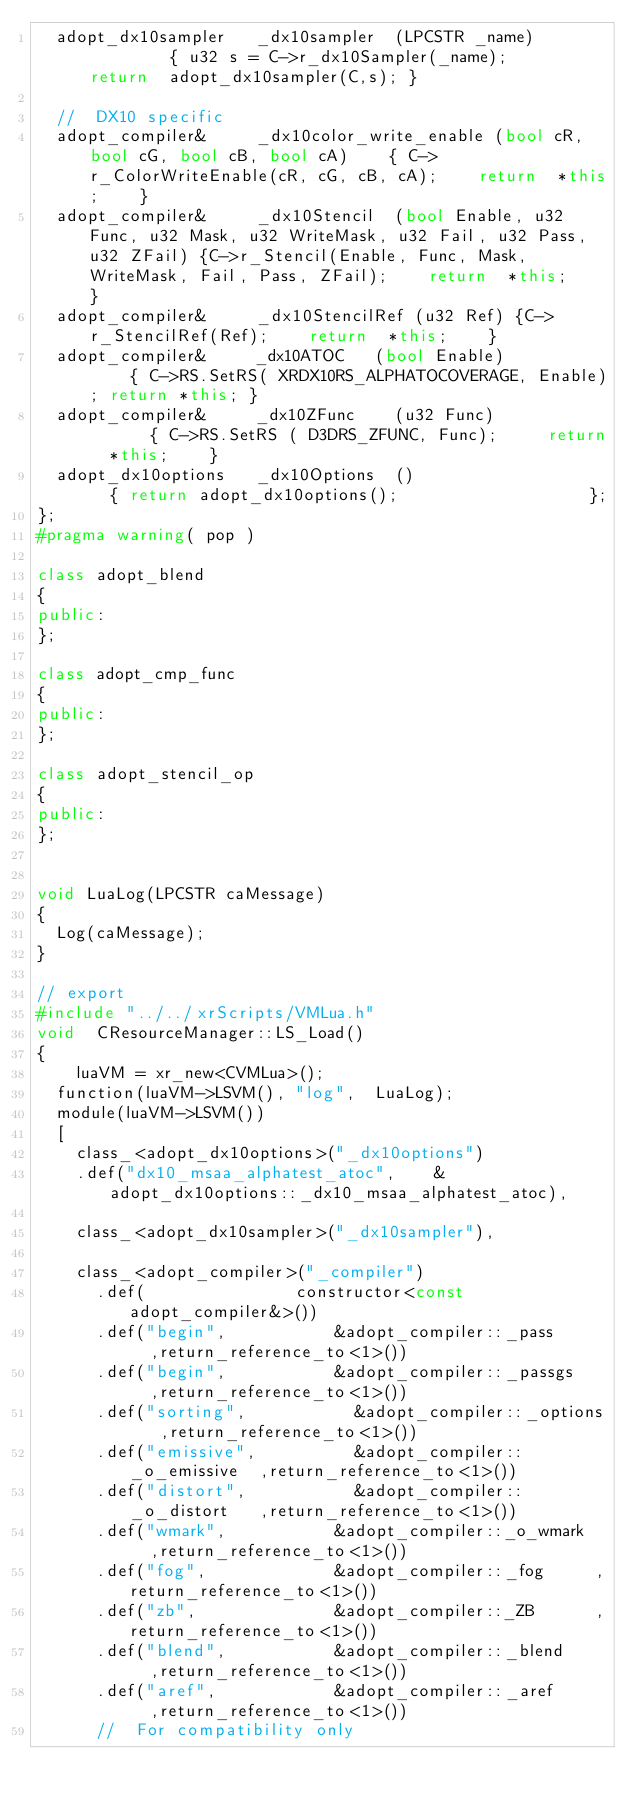Convert code to text. <code><loc_0><loc_0><loc_500><loc_500><_C++_>	adopt_dx10sampler		_dx10sampler	(LPCSTR _name)							{	u32 s = C->r_dx10Sampler(_name);			return	adopt_dx10sampler(C,s);	}

	//	DX10 specific
	adopt_compiler&			_dx10color_write_enable (bool cR, bool cG, bool cB, bool cA)		{	C->r_ColorWriteEnable(cR, cG, cB, cA);		return	*this;		}
	adopt_compiler&			_dx10Stencil	(bool Enable, u32 Func, u32 Mask, u32 WriteMask, u32 Fail, u32 Pass, u32 ZFail) {C->r_Stencil(Enable, Func, Mask, WriteMask, Fail, Pass, ZFail);		return	*this;		}
	adopt_compiler&			_dx10StencilRef	(u32 Ref) {C->r_StencilRef(Ref);		return	*this;		}
	adopt_compiler&			_dx10ATOC		(bool Enable)							{	C->RS.SetRS( XRDX10RS_ALPHATOCOVERAGE, Enable);	return *this;	}
	adopt_compiler&			_dx10ZFunc		(u32 Func)								{	C->RS.SetRS	( D3DRS_ZFUNC, Func);			return	*this;		}
	adopt_dx10options		_dx10Options	()										{	return adopt_dx10options();										};
};
#pragma warning( pop )

class	adopt_blend
{
public:
};

class	adopt_cmp_func
{
public:
};

class	adopt_stencil_op
{
public:
};


void LuaLog(LPCSTR caMessage)
{
	Log(caMessage);
}

// export
#include "../../xrScripts/VMLua.h"
void	CResourceManager::LS_Load()
{
    luaVM = xr_new<CVMLua>();
	function(luaVM->LSVM(), "log",	LuaLog);
	module(luaVM->LSVM())
	[
		class_<adopt_dx10options>("_dx10options")
		.def("dx10_msaa_alphatest_atoc",		&adopt_dx10options::_dx10_msaa_alphatest_atoc),

		class_<adopt_dx10sampler>("_dx10sampler"),

		class_<adopt_compiler>("_compiler")
			.def(								constructor<const adopt_compiler&>())
			.def("begin",						&adopt_compiler::_pass			,return_reference_to<1>())
			.def("begin",						&adopt_compiler::_passgs		,return_reference_to<1>())
			.def("sorting",						&adopt_compiler::_options		,return_reference_to<1>())
			.def("emissive",					&adopt_compiler::_o_emissive	,return_reference_to<1>())
			.def("distort",						&adopt_compiler::_o_distort		,return_reference_to<1>())
			.def("wmark",						&adopt_compiler::_o_wmark		,return_reference_to<1>())
			.def("fog",							&adopt_compiler::_fog			,return_reference_to<1>())
			.def("zb",							&adopt_compiler::_ZB			,return_reference_to<1>())
			.def("blend",						&adopt_compiler::_blend			,return_reference_to<1>())
			.def("aref",						&adopt_compiler::_aref			,return_reference_to<1>())
			//	For compatibility only</code> 